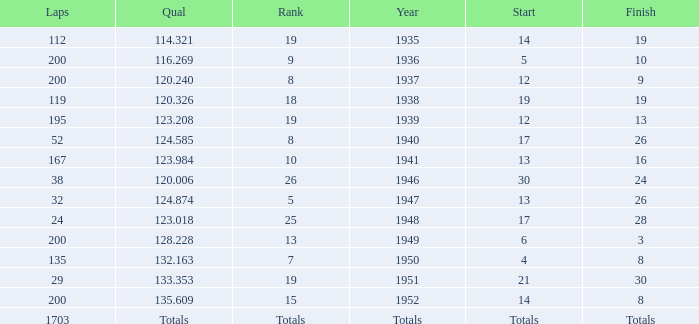The Qual of 120.006 took place in what year? 1946.0. 